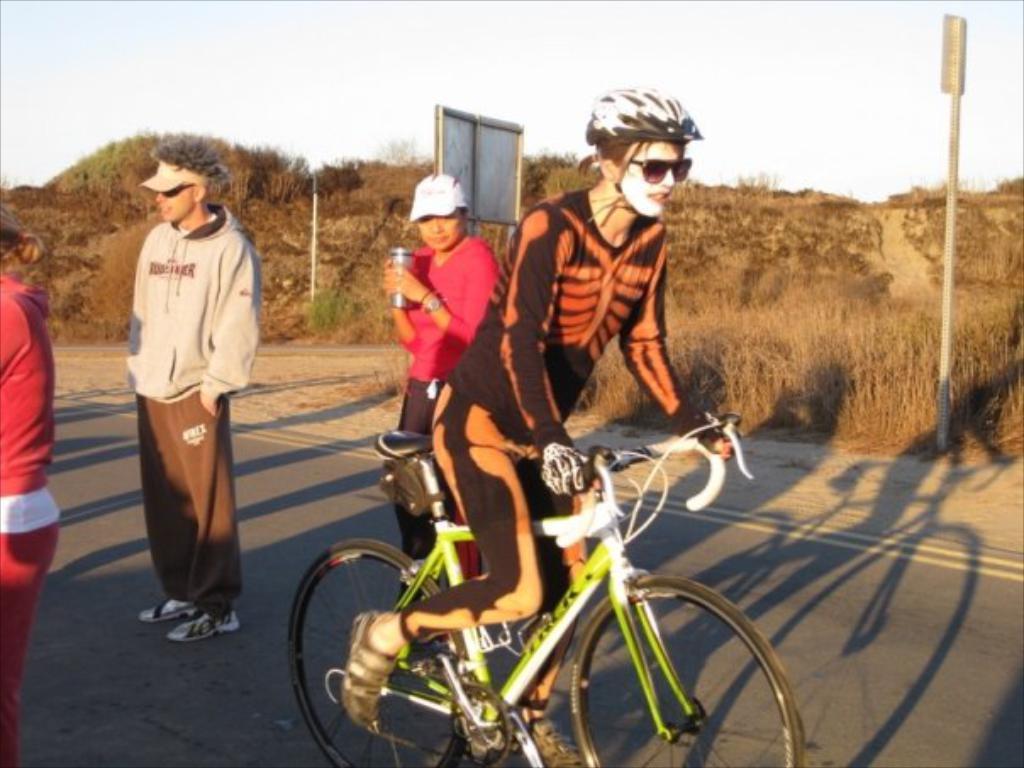How would you summarize this image in a sentence or two? In this picture on the road there is a lady with skeleton mask is riding a bicycle. She is wearing helmet on his head. To the left side there is a person with pink dress is stunning. Behind that person there is a man with grey jacket is standing. To the side of him there is another lady with pink dress is standing and holding bottle in her hand and wearing cap on her head. In the background there is a board and hills with dry grass. 